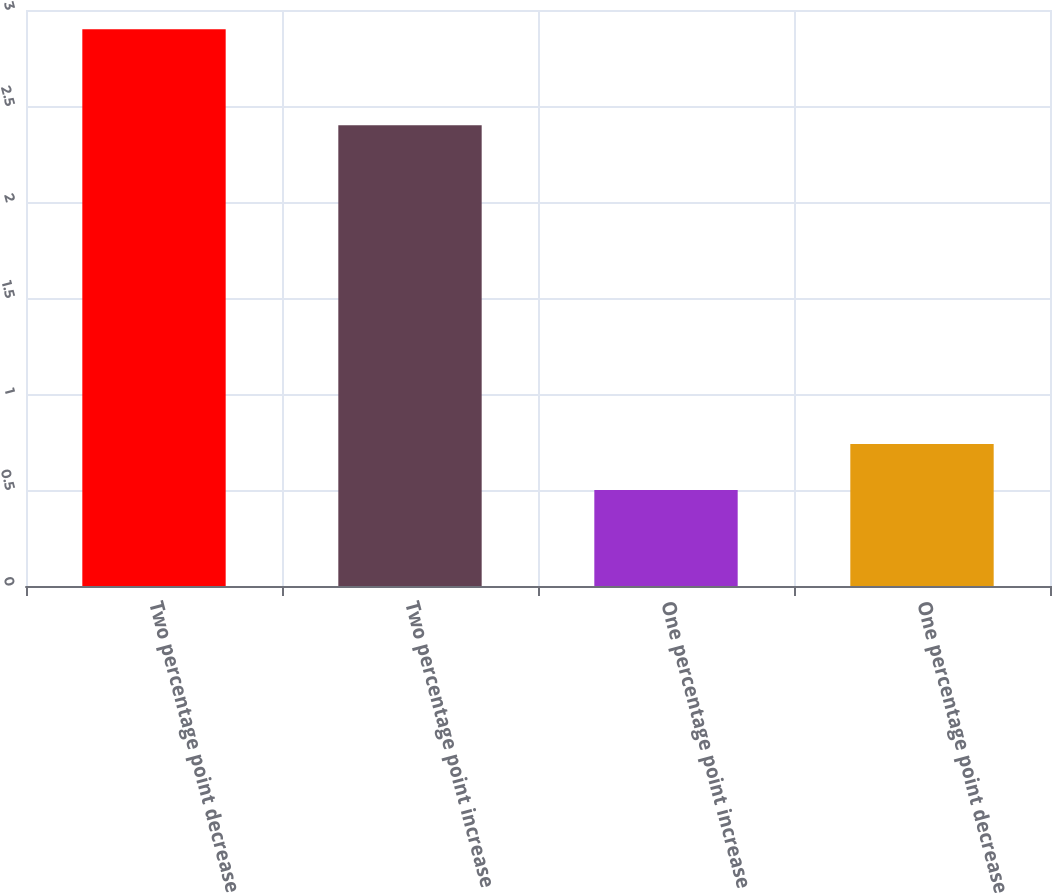Convert chart. <chart><loc_0><loc_0><loc_500><loc_500><bar_chart><fcel>Two percentage point decrease<fcel>Two percentage point increase<fcel>One percentage point increase<fcel>One percentage point decrease<nl><fcel>2.9<fcel>2.4<fcel>0.5<fcel>0.74<nl></chart> 